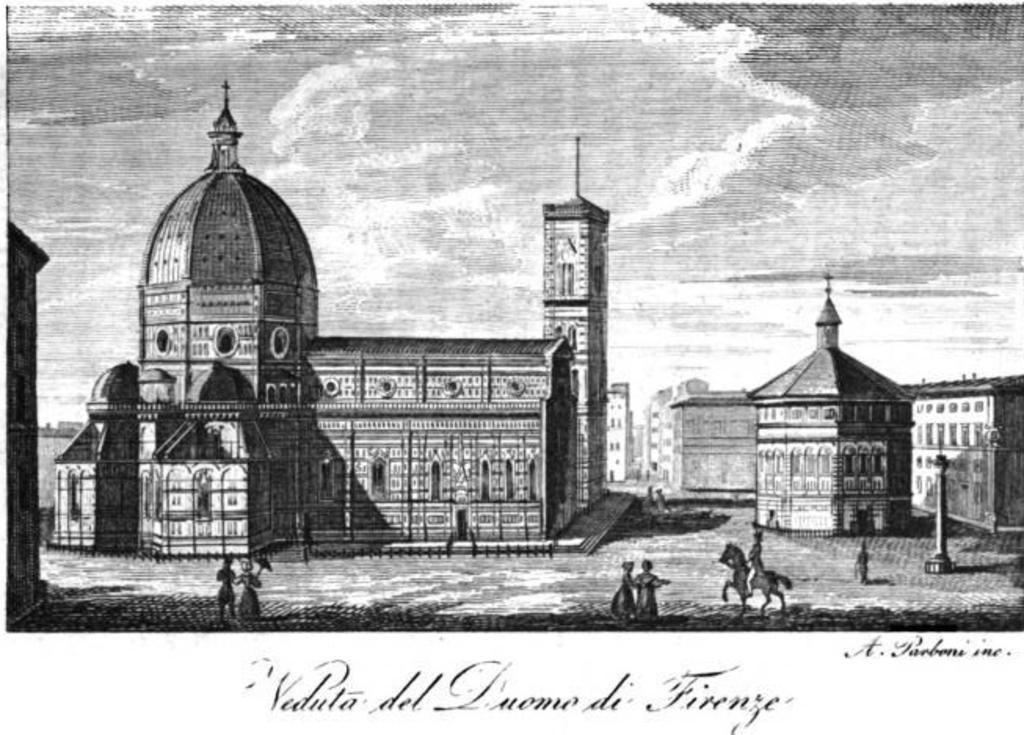What is the color scheme of the painting in the image? The painting is black and white. What else can be seen on the painting besides the color scheme? There is writing on the painting. What type of objects or structures are depicted in the painting? There are buildings and people depicted in the painting. Can you describe a specific scene or figure in the painting? There is a man on a horse in the painting. What type of adjustment is needed for the plate in the painting? There is no plate present in the painting, so no adjustment is needed. 